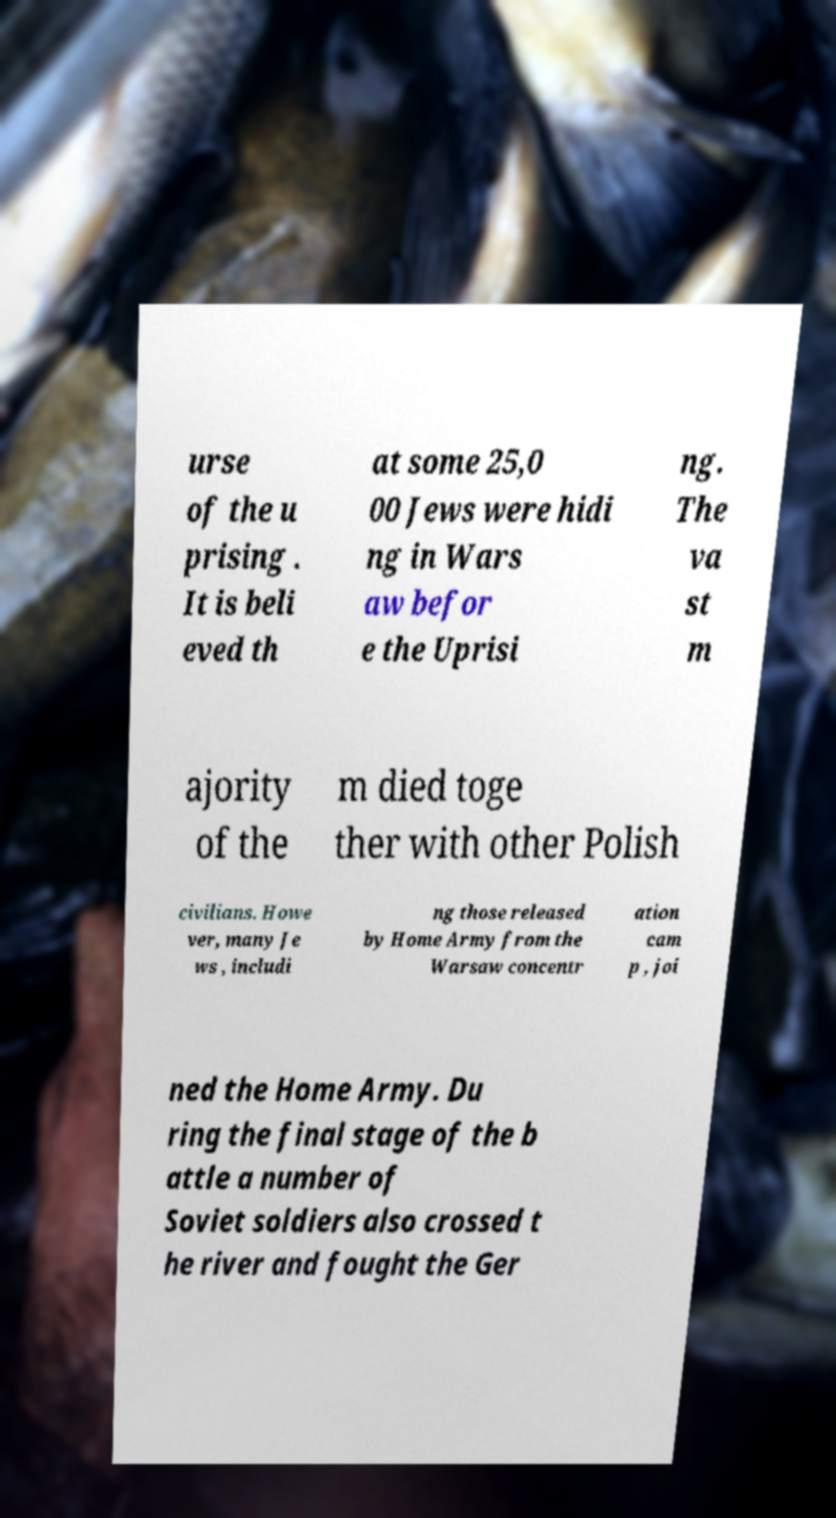Can you read and provide the text displayed in the image?This photo seems to have some interesting text. Can you extract and type it out for me? urse of the u prising . It is beli eved th at some 25,0 00 Jews were hidi ng in Wars aw befor e the Uprisi ng. The va st m ajority of the m died toge ther with other Polish civilians. Howe ver, many Je ws , includi ng those released by Home Army from the Warsaw concentr ation cam p , joi ned the Home Army. Du ring the final stage of the b attle a number of Soviet soldiers also crossed t he river and fought the Ger 